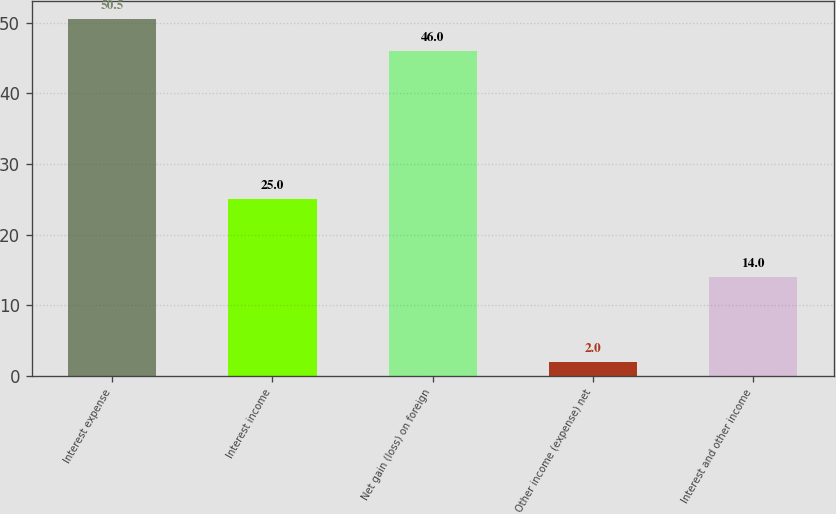<chart> <loc_0><loc_0><loc_500><loc_500><bar_chart><fcel>Interest expense<fcel>Interest income<fcel>Net gain (loss) on foreign<fcel>Other income (expense) net<fcel>Interest and other income<nl><fcel>50.5<fcel>25<fcel>46<fcel>2<fcel>14<nl></chart> 